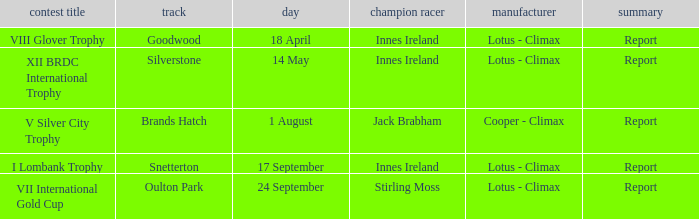What is the name of the race where Stirling Moss was the winning driver? VII International Gold Cup. 